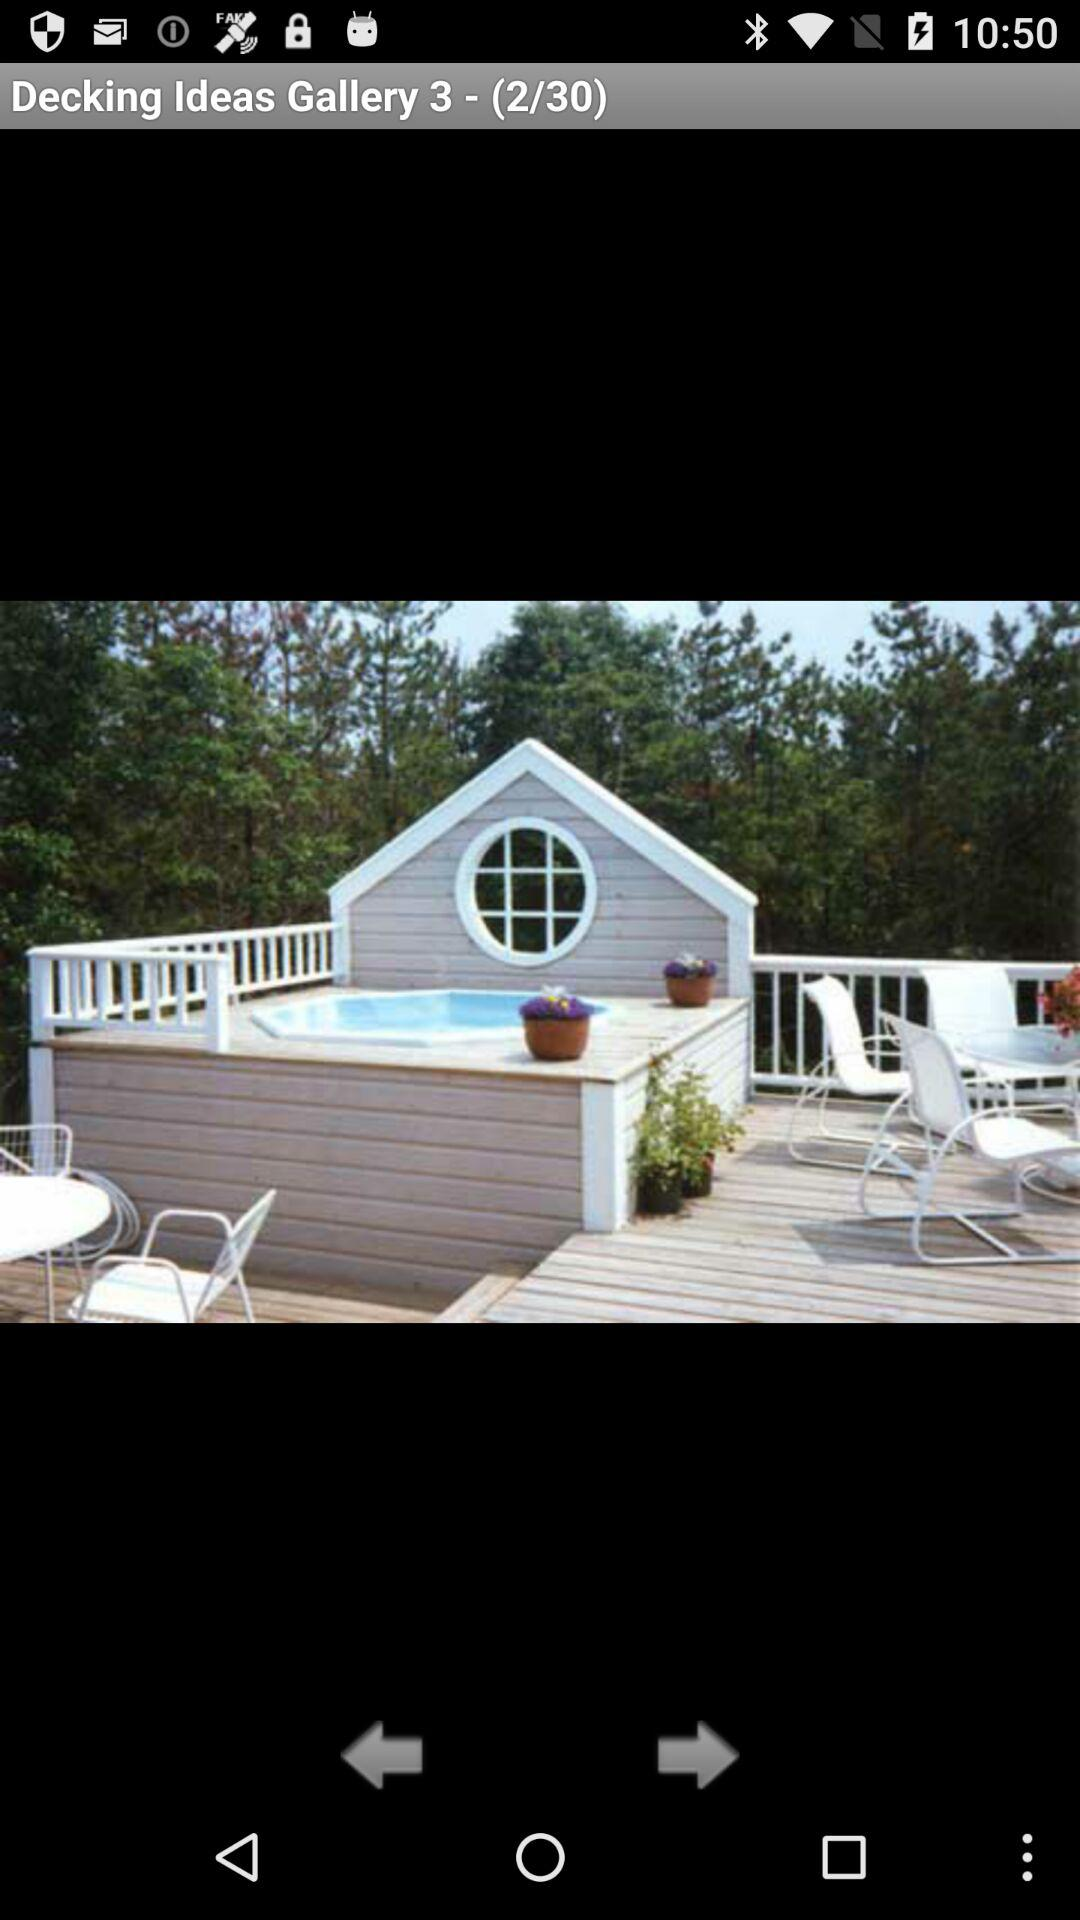Which photo number is currently shown on the screen? The photo number currently shown on the screen is 2. 